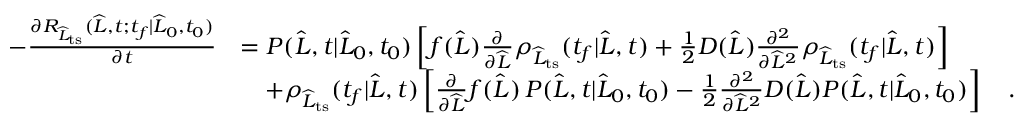<formula> <loc_0><loc_0><loc_500><loc_500>\begin{array} { r l } { - \frac { \partial R _ { \widehat { L } _ { t s } } ( \widehat { L } , t ; t _ { f } | \widehat { L } _ { 0 } , t _ { 0 } ) } { \partial t } } & { = P ( \widehat { L } , t | \widehat { L } _ { 0 } , t _ { 0 } ) \left [ f ( \widehat { L } ) \frac { \partial } { \partial \widehat { L } } \rho _ { \widehat { L } _ { t s } } ( t _ { f } | \widehat { L } , t ) + \frac { 1 } { 2 } D ( \widehat { L } ) \frac { \partial ^ { 2 } } { \partial \widehat { L } ^ { 2 } } \rho _ { \widehat { L } _ { t s } } ( t _ { f } | \widehat { L } , t ) \right ] } \\ & { \quad + \rho _ { \widehat { L } _ { t s } } ( t _ { f } | \widehat { L } , t ) \left [ \frac { \partial } { \partial \widehat { L } } f ( \widehat { L } ) \, P ( \widehat { L } , t | \widehat { L } _ { 0 } , t _ { 0 } ) - \frac { 1 } { 2 } \frac { \partial ^ { 2 } } { \partial \widehat { L } ^ { 2 } } D ( \widehat { L } ) P ( \widehat { L } , t | \widehat { L } _ { 0 } , t _ { 0 } ) \right ] \quad . } \end{array}</formula> 